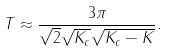<formula> <loc_0><loc_0><loc_500><loc_500>T \approx \frac { 3 \pi } { \sqrt { 2 } \sqrt { K _ { c } } \sqrt { K _ { c } - K } } .</formula> 